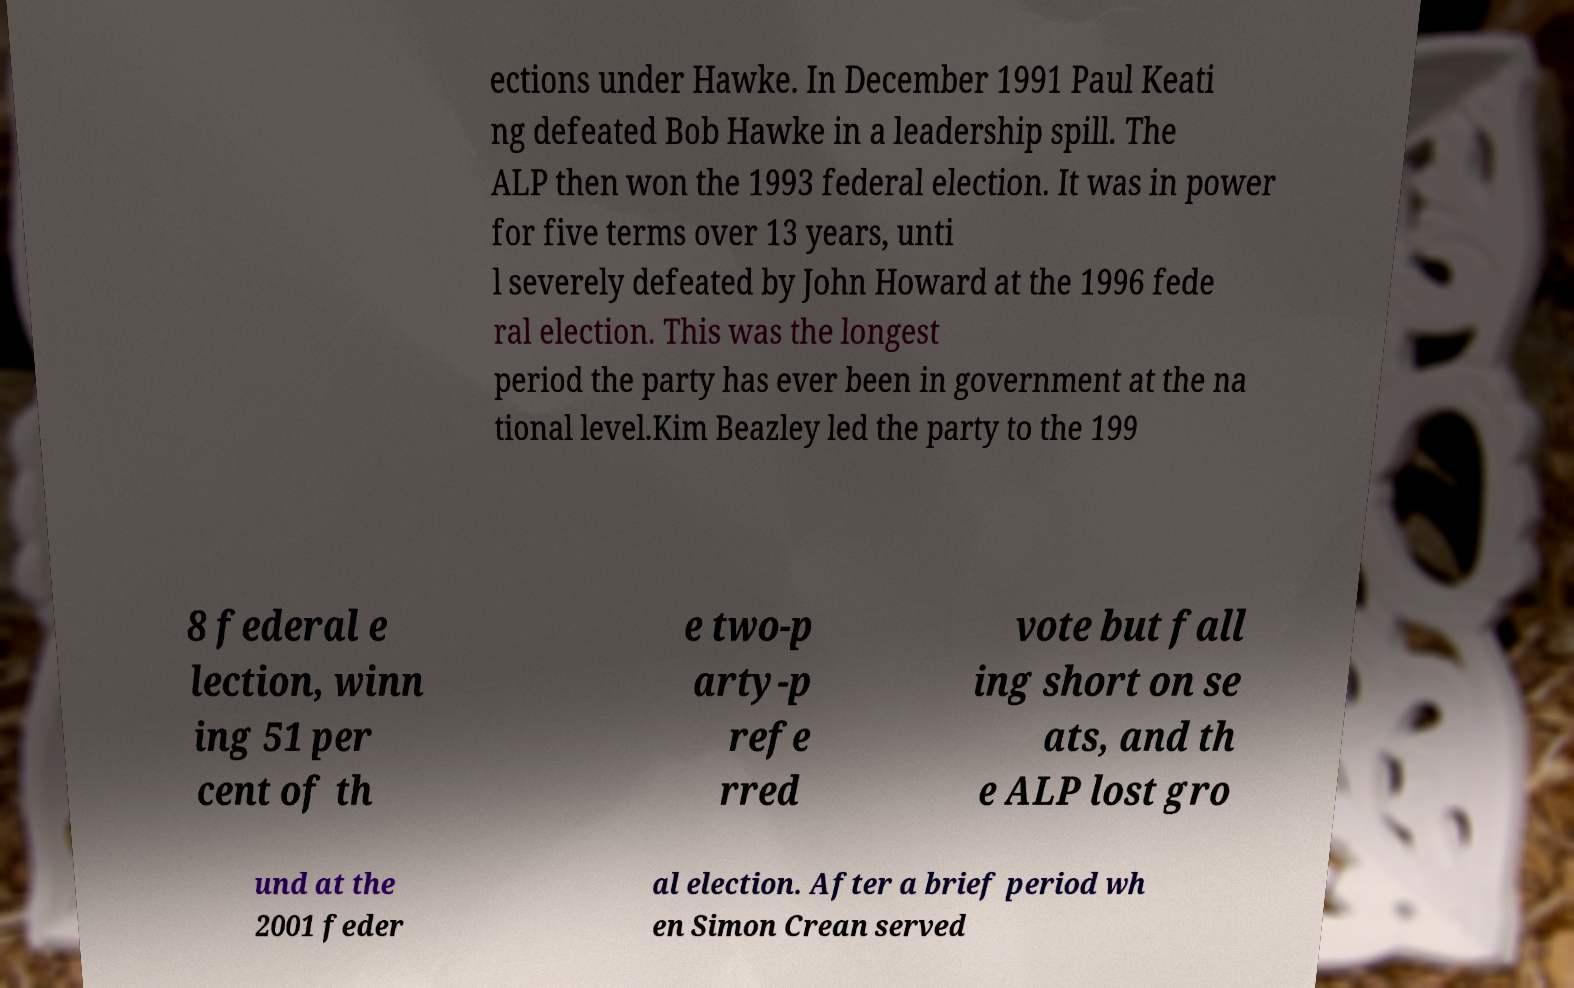Could you assist in decoding the text presented in this image and type it out clearly? ections under Hawke. In December 1991 Paul Keati ng defeated Bob Hawke in a leadership spill. The ALP then won the 1993 federal election. It was in power for five terms over 13 years, unti l severely defeated by John Howard at the 1996 fede ral election. This was the longest period the party has ever been in government at the na tional level.Kim Beazley led the party to the 199 8 federal e lection, winn ing 51 per cent of th e two-p arty-p refe rred vote but fall ing short on se ats, and th e ALP lost gro und at the 2001 feder al election. After a brief period wh en Simon Crean served 